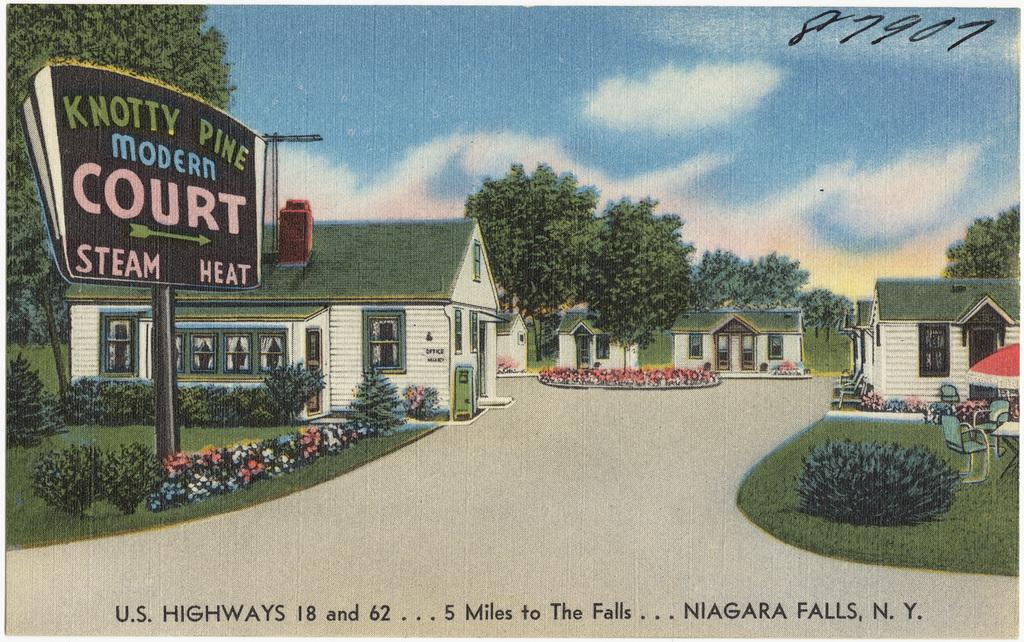What type of image is shown in the picture? The image is a poster. What structures are depicted on the poster? There are houses and trees depicted on the poster. What other object is shown on the poster? There is a board depicted on the poster. Can you see any goldfish swimming in the water on the poster? There are no goldfish or water depicted on the poster; it features houses, trees, and a board. What emotion is being expressed by the houses and trees on the poster? The poster does not depict emotions, as it is an inanimate representation of houses, trees, and a board. 